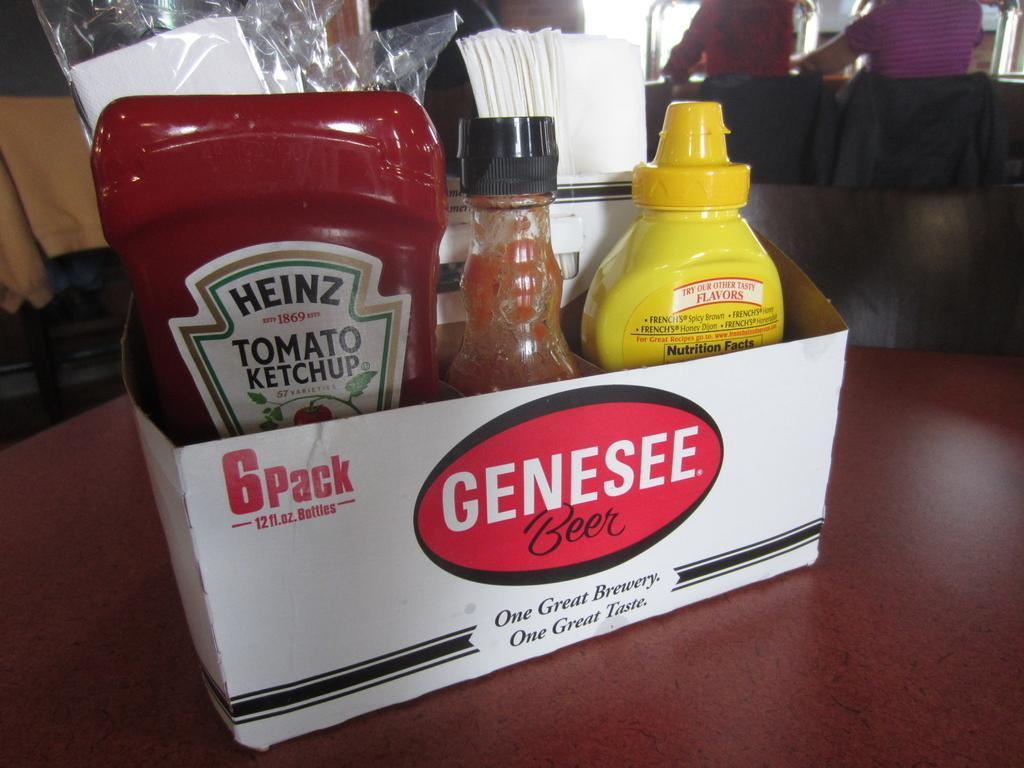<image>
Offer a succinct explanation of the picture presented. A cardboard box that says Genesee Beer on it is holding condiments. 